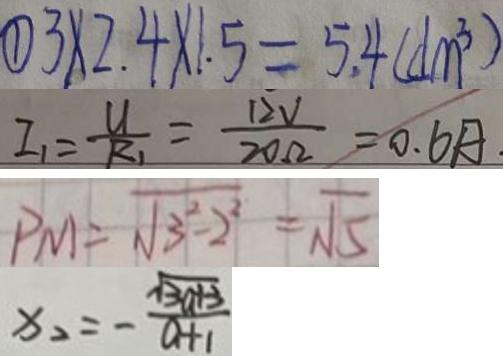Convert formula to latex. <formula><loc_0><loc_0><loc_500><loc_500>\textcircled { 1 } 3 \times 2 . 4 \times 1 . 5 = 5 . 4 ( d m ^ { 3 } ) 
 I _ { 1 } = \frac { U } { R _ { 1 } } = \frac { 1 2 V } { 2 0 \Omega } = 0 . 6 A . 
 P M = \sqrt { 3 ^ { 2 } - 2 ^ { 2 } } = \sqrt { 5 } 
 x _ { 2 } = - \frac { \sqrt { 3 a + 3 } } { a + 1 }</formula> 